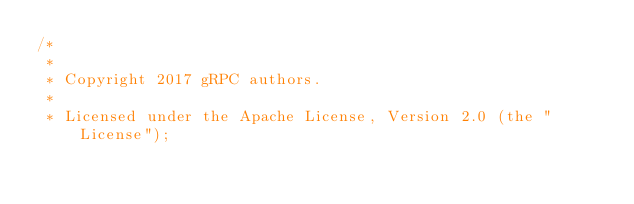Convert code to text. <code><loc_0><loc_0><loc_500><loc_500><_C++_>/*
 *
 * Copyright 2017 gRPC authors.
 *
 * Licensed under the Apache License, Version 2.0 (the "License");</code> 